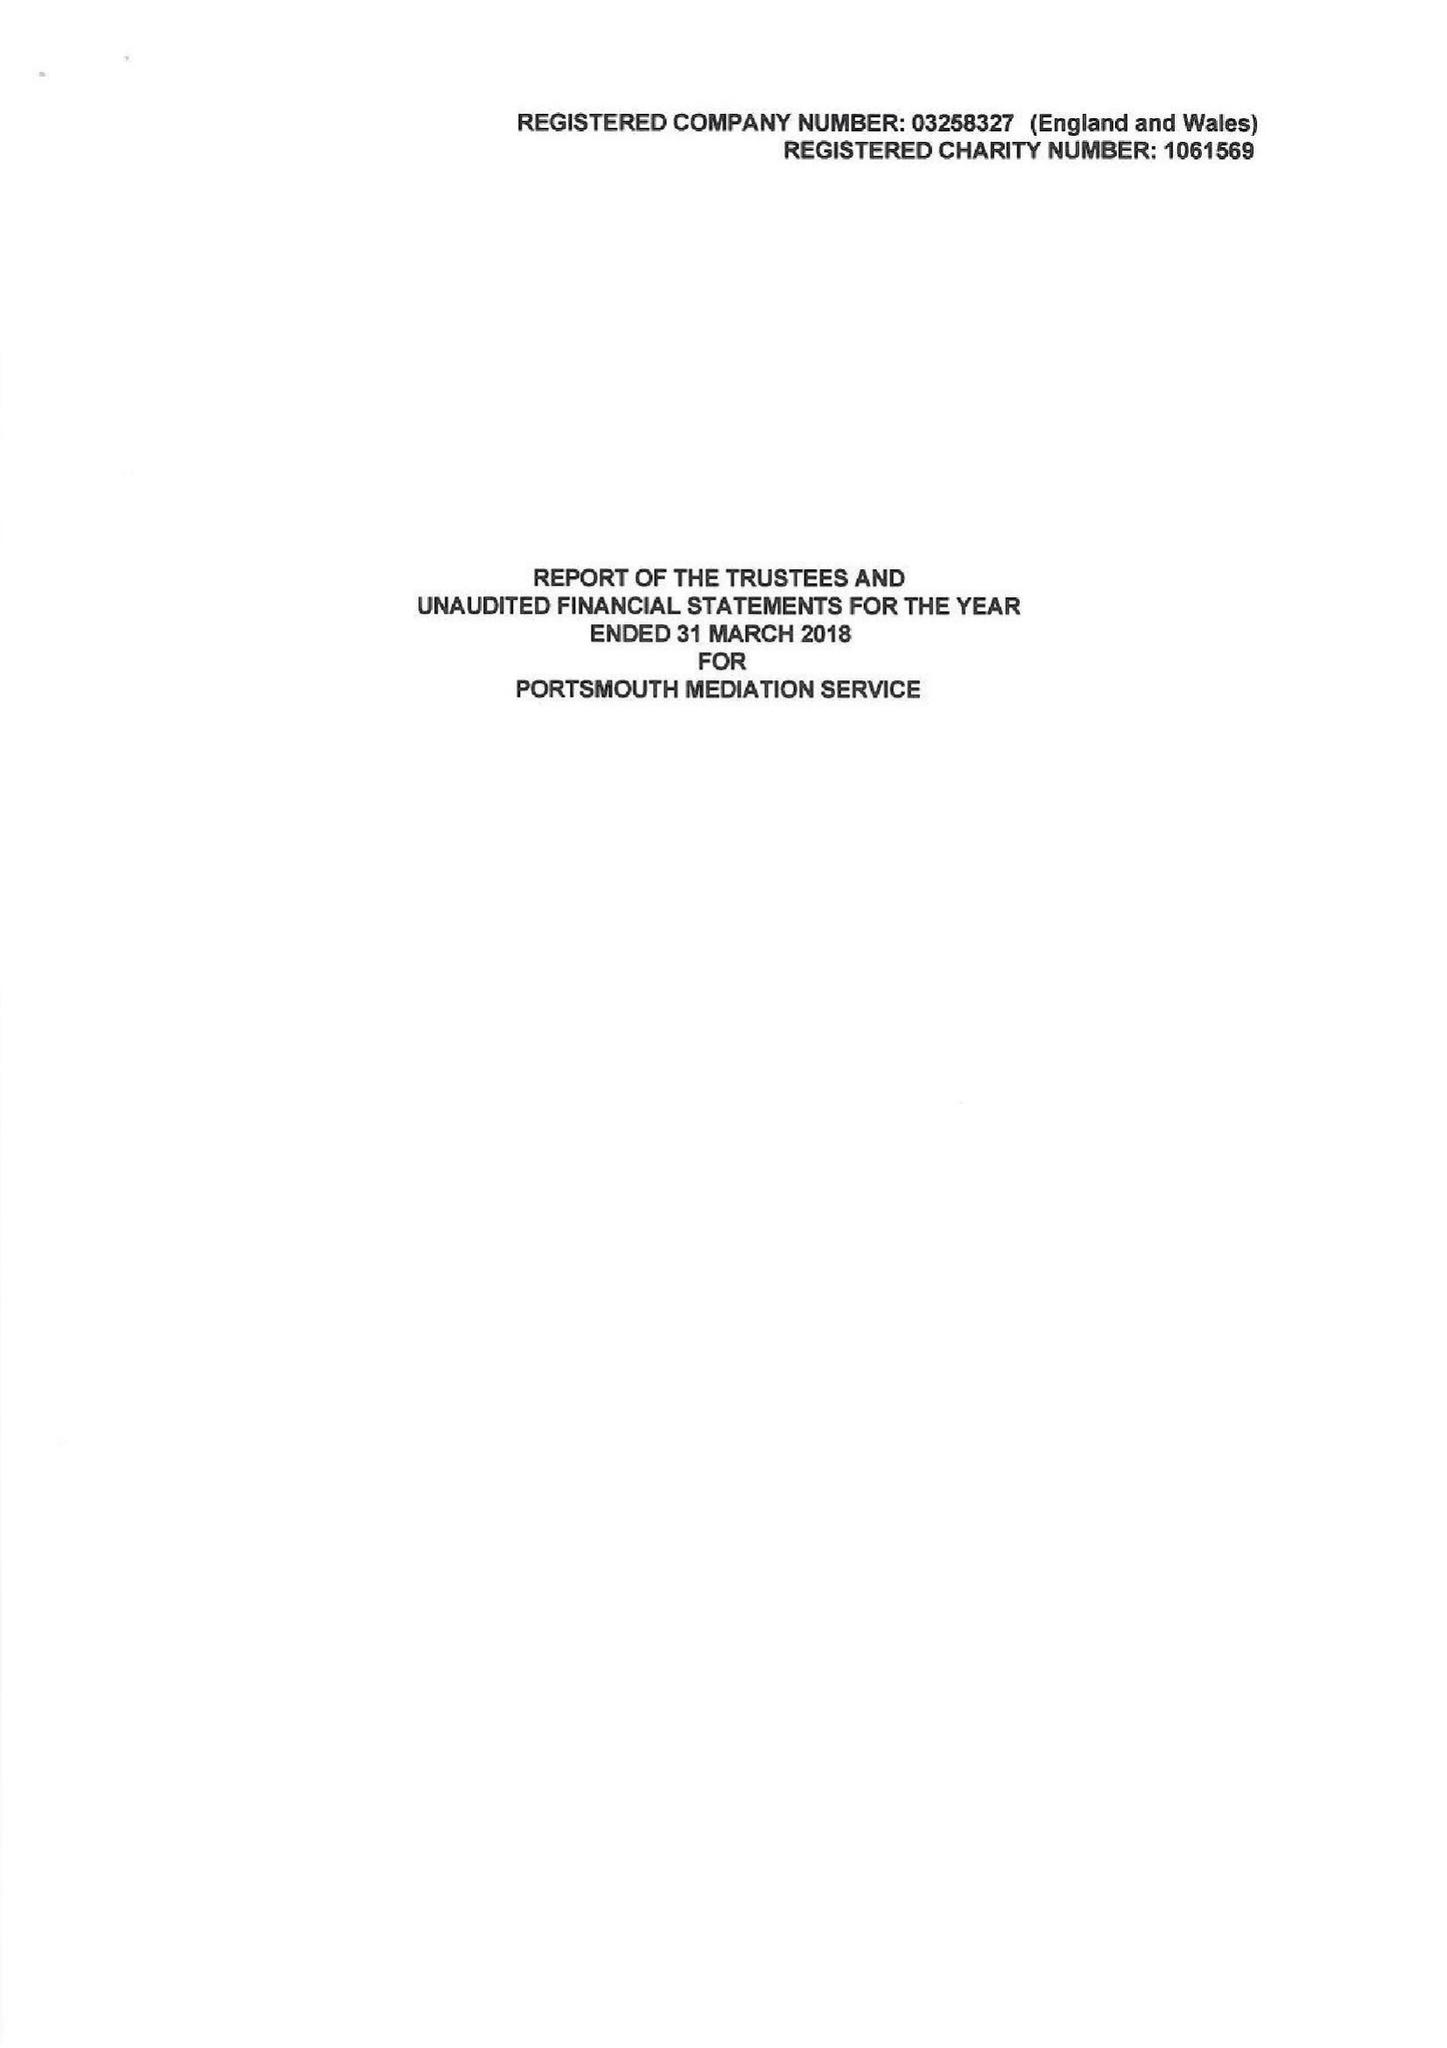What is the value for the address__post_town?
Answer the question using a single word or phrase. PORTSMOUTH 